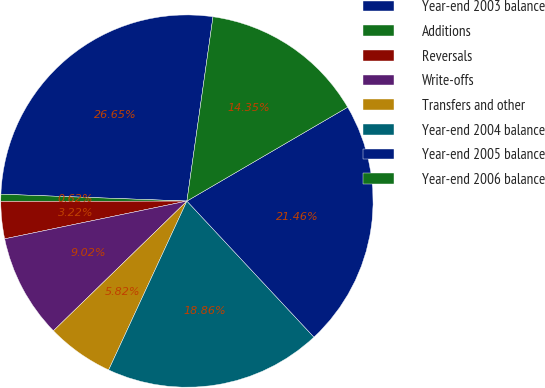Convert chart. <chart><loc_0><loc_0><loc_500><loc_500><pie_chart><fcel>Year-end 2003 balance<fcel>Additions<fcel>Reversals<fcel>Write-offs<fcel>Transfers and other<fcel>Year-end 2004 balance<fcel>Year-end 2005 balance<fcel>Year-end 2006 balance<nl><fcel>26.65%<fcel>0.62%<fcel>3.22%<fcel>9.02%<fcel>5.82%<fcel>18.86%<fcel>21.46%<fcel>14.35%<nl></chart> 